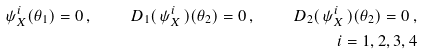<formula> <loc_0><loc_0><loc_500><loc_500>\psi ^ { i } _ { X } ( \theta _ { 1 } ) = 0 \, , \quad D _ { 1 } ( \, \psi ^ { i } _ { X } \, ) ( \theta _ { 2 } ) = 0 \, , \quad D _ { 2 } ( \, \psi ^ { i } _ { X } \, ) ( \theta _ { 2 } ) = 0 \, , \\ i = 1 , 2 , 3 , 4</formula> 